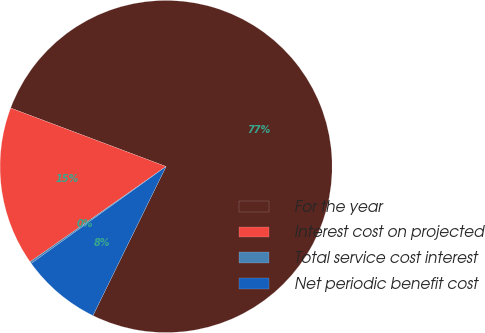Convert chart to OTSL. <chart><loc_0><loc_0><loc_500><loc_500><pie_chart><fcel>For the year<fcel>Interest cost on projected<fcel>Total service cost interest<fcel>Net periodic benefit cost<nl><fcel>76.53%<fcel>15.46%<fcel>0.19%<fcel>7.82%<nl></chart> 